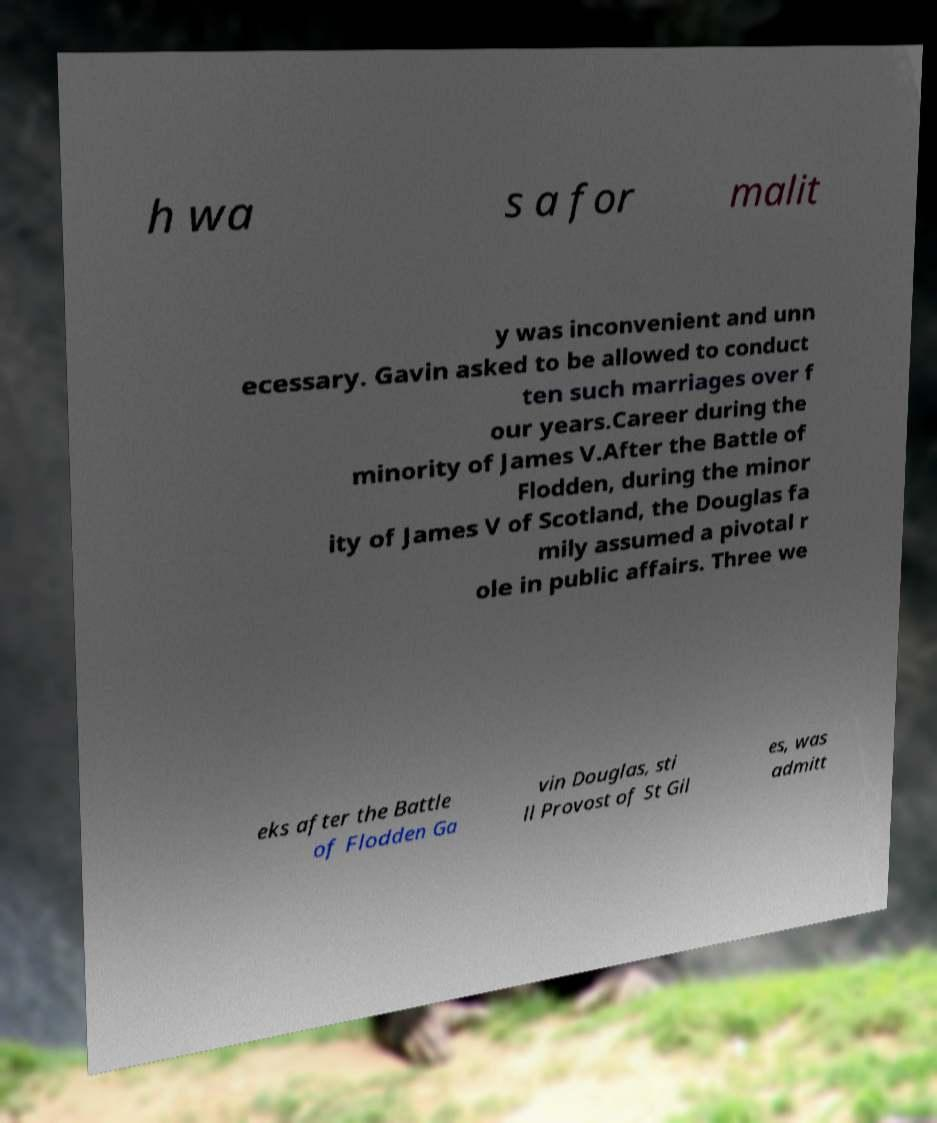Please identify and transcribe the text found in this image. h wa s a for malit y was inconvenient and unn ecessary. Gavin asked to be allowed to conduct ten such marriages over f our years.Career during the minority of James V.After the Battle of Flodden, during the minor ity of James V of Scotland, the Douglas fa mily assumed a pivotal r ole in public affairs. Three we eks after the Battle of Flodden Ga vin Douglas, sti ll Provost of St Gil es, was admitt 